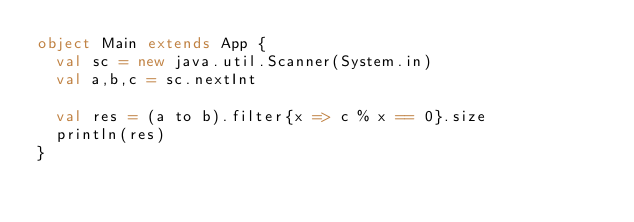Convert code to text. <code><loc_0><loc_0><loc_500><loc_500><_Scala_>object Main extends App {
  val sc = new java.util.Scanner(System.in)
  val a,b,c = sc.nextInt
  
  val res = (a to b).filter{x => c % x == 0}.size
  println(res)
}
</code> 